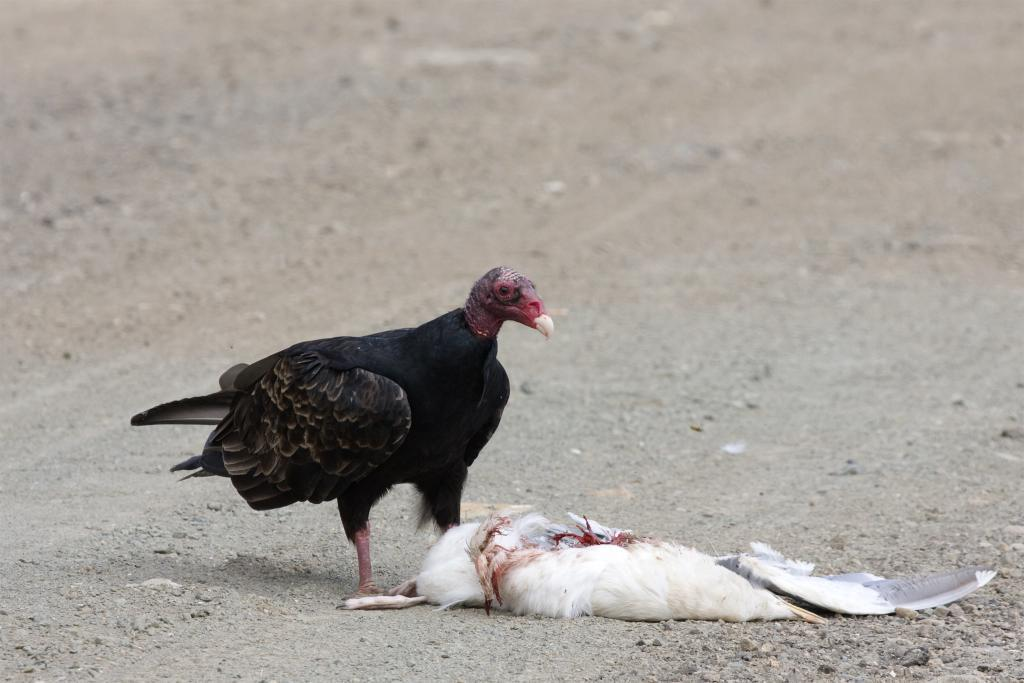What color is the bird that is alive in the image? There is a black color bird in the image. What is the condition of the other bird in the image? There is a white color dead bird in the image. Where are both birds located in the image? Both birds are visible on the road. How many firemen are present in the image? There are no firemen present in the image; it features two birds on the road. What type of animal is grazing in the background of the image? There is no background visible in the image, and no animals are mentioned in the provided facts. 